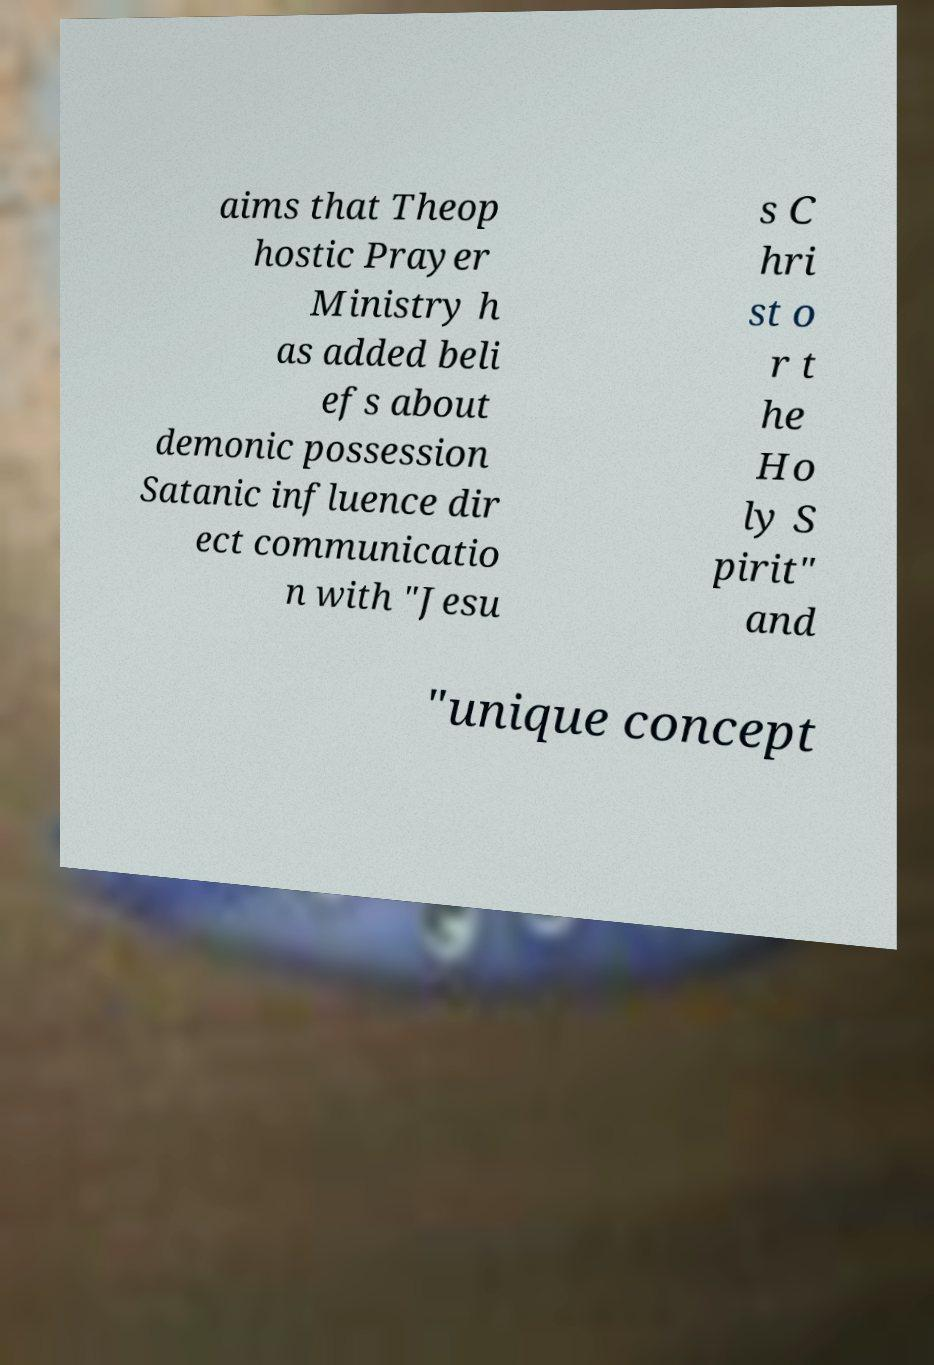Could you assist in decoding the text presented in this image and type it out clearly? aims that Theop hostic Prayer Ministry h as added beli efs about demonic possession Satanic influence dir ect communicatio n with "Jesu s C hri st o r t he Ho ly S pirit" and "unique concept 